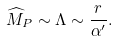<formula> <loc_0><loc_0><loc_500><loc_500>\widehat { M } _ { P } \sim \Lambda \sim \frac { r } { \alpha ^ { \prime } } .</formula> 